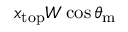Convert formula to latex. <formula><loc_0><loc_0><loc_500><loc_500>x _ { t o p } W \cos \theta _ { m }</formula> 